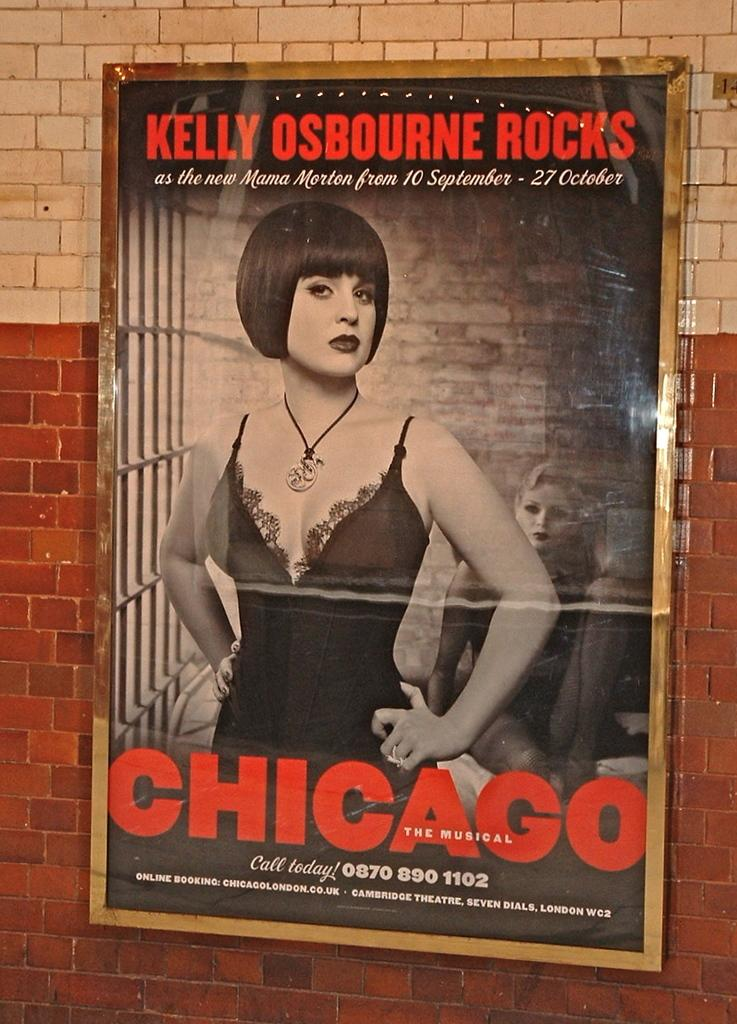<image>
Write a terse but informative summary of the picture. Kelly Osbourne stars in Chicago playing in London. 